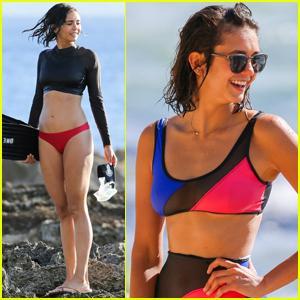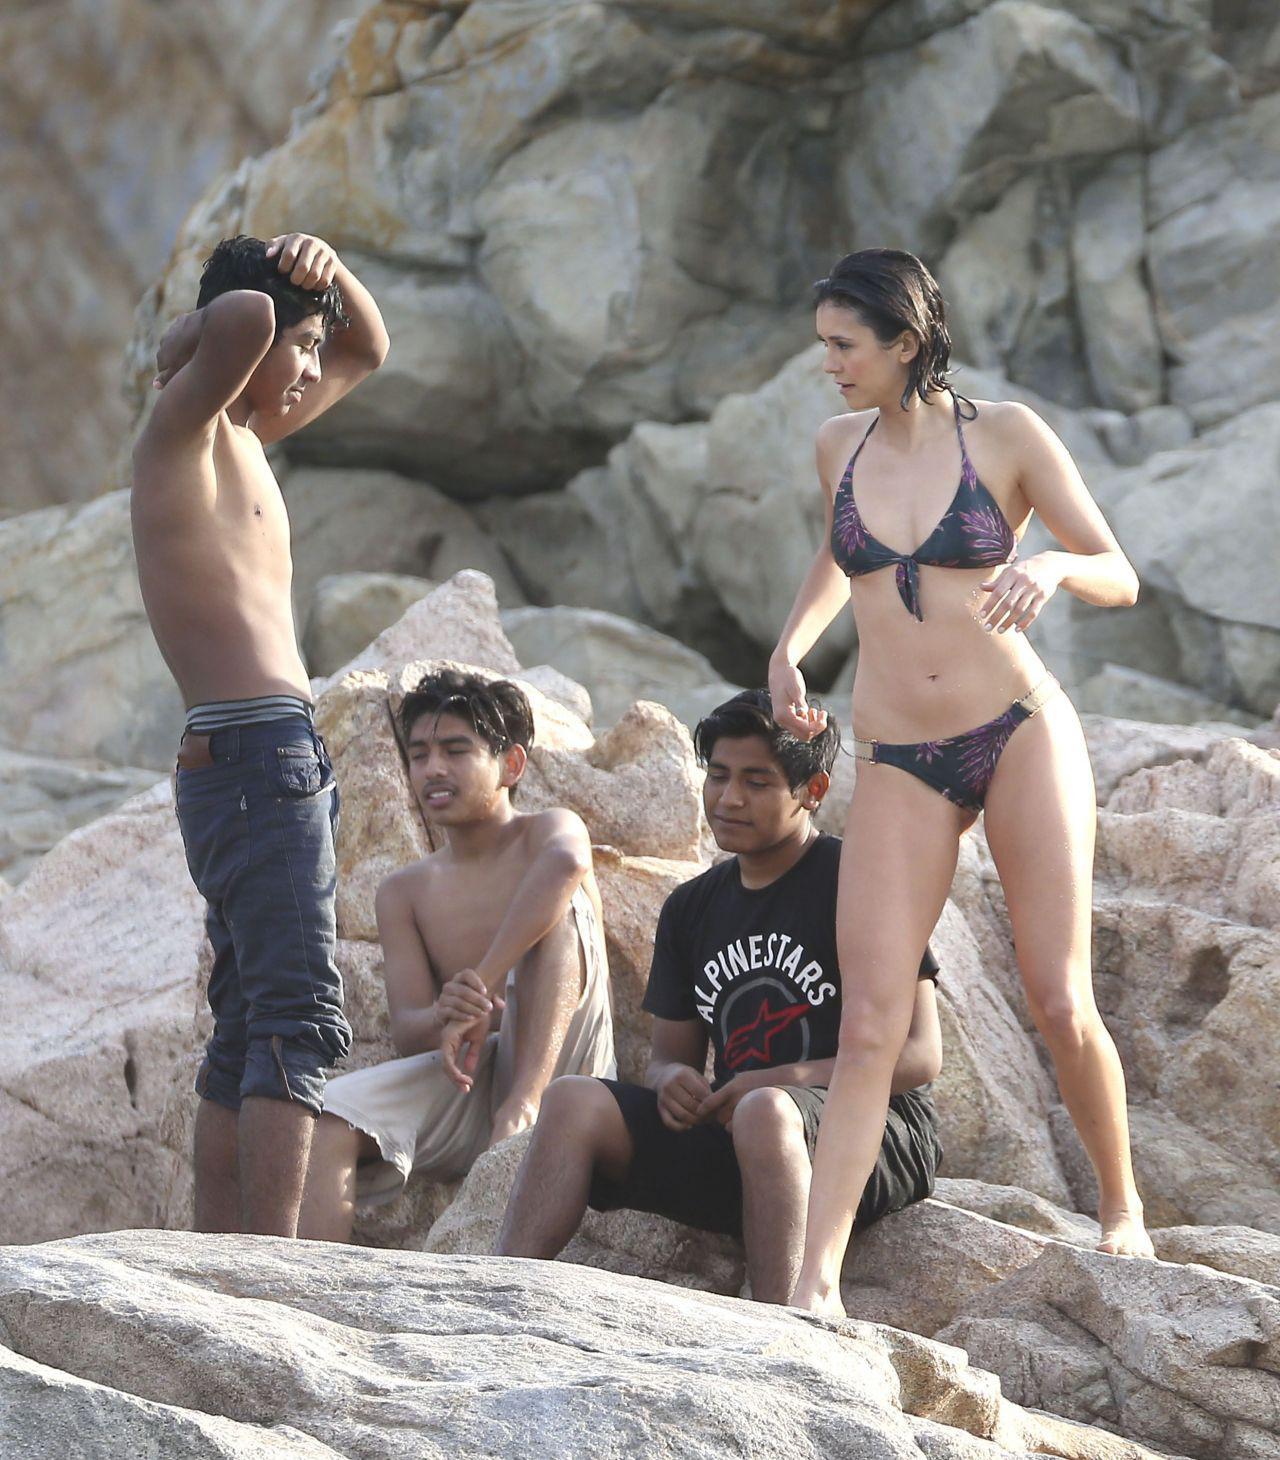The first image is the image on the left, the second image is the image on the right. Assess this claim about the two images: "The right image shows a woman in a red bikini top and a woman in a blue bikini top looking at a camera together". Correct or not? Answer yes or no. No. The first image is the image on the left, the second image is the image on the right. Considering the images on both sides, is "There are two women wearing swimsuits in the image on the left." valid? Answer yes or no. Yes. 